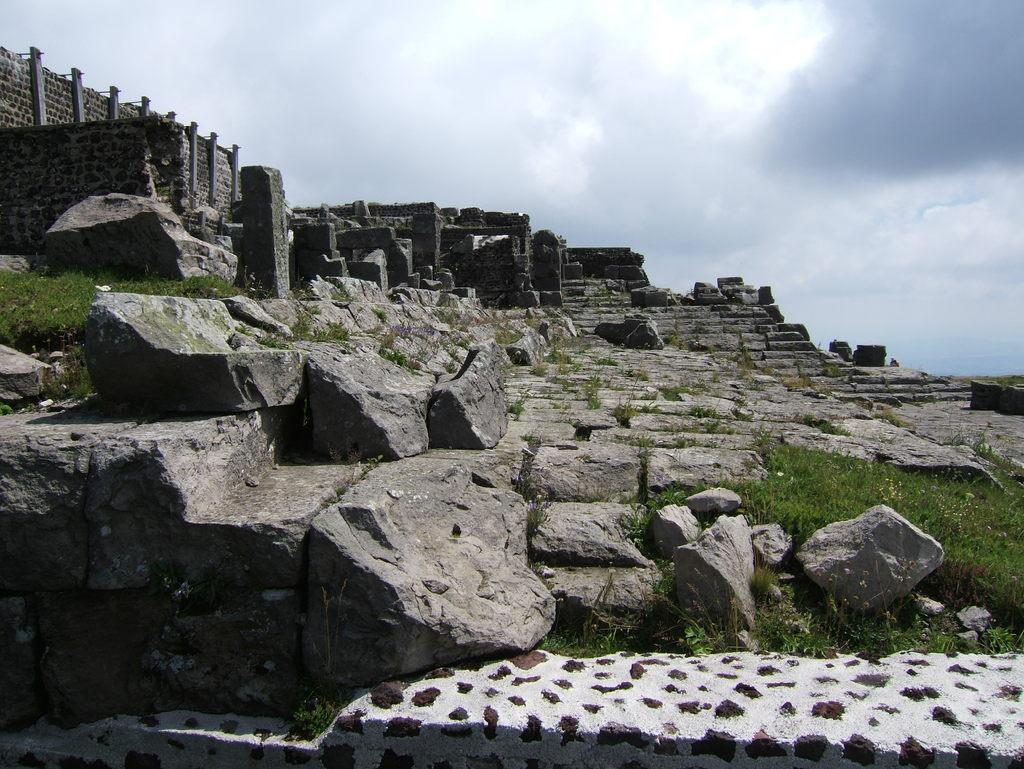What type of natural environment is visible in the image? There is grass in the image, which suggests a natural environment. What other elements can be seen in the image? There are rocks and a stone wall visible in the image. What is visible in the background of the image? The sky is visible in the background of the image. How would you describe the sky in the image? The sky appears to be cloudy in the image. What type of sign or advertisement can be seen on the stone wall in the image? There is no sign or advertisement present on the stone wall in the image. What type of apparel is the grass wearing in the image? Grass does not wear apparel, as it is a natural element and not a living being. 